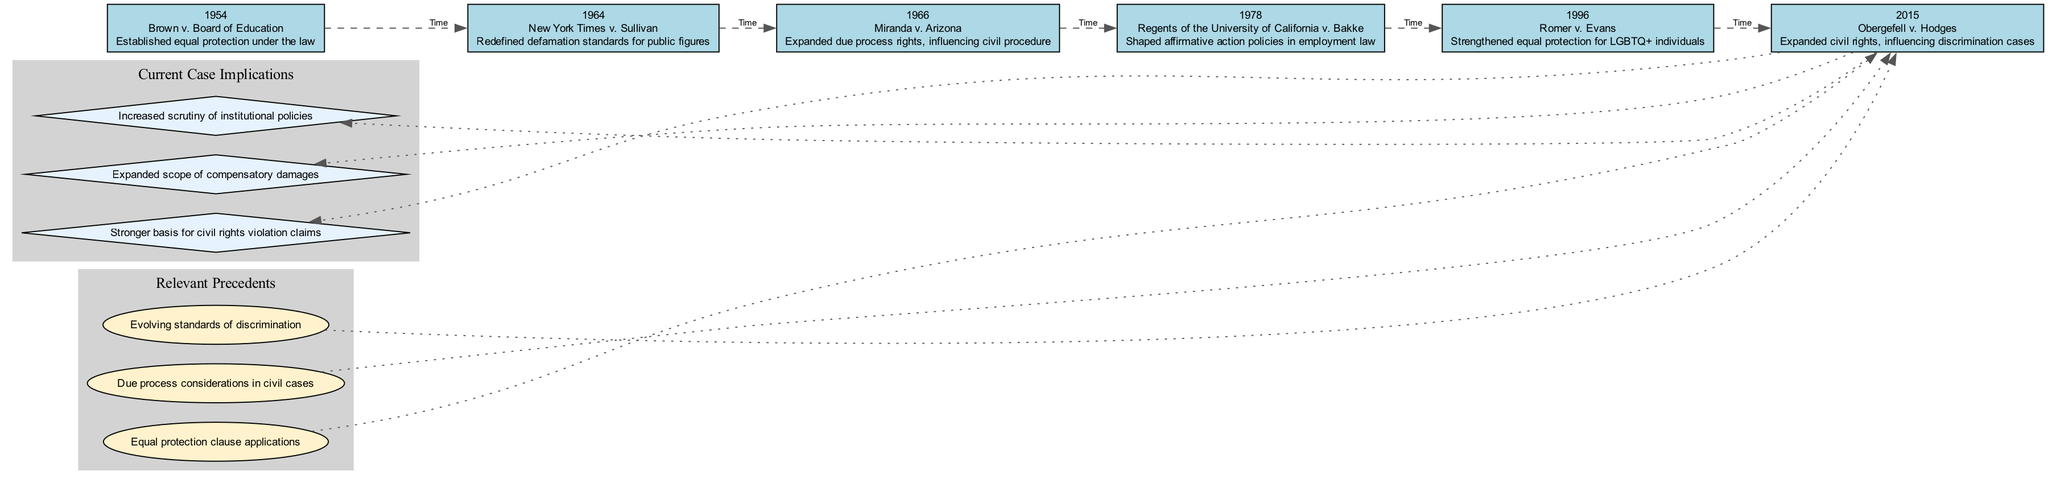What year did Brown v. Board of Education occur? The diagram lists "Brown v. Board of Education" under the year 1954, which is indicated as the first entry in the timeline.
Answer: 1954 How many cases are represented in the timeline? The timeline includes six cases, which can be counted from the list provided.
Answer: 6 What was the impact of Obergefell v. Hodges? The diagram states that "Obergefell v. Hodges" expanded civil rights and influenced discrimination cases, as indicated in the description for that particular case.
Answer: Expanded civil rights, influencing discrimination cases Which case had an impact on affirmative action policies? The diagram specifies that the impact of "Regents of the University of California v. Bakke" was to shape affirmative action policies in employment law, which is mentioned right after the year and case name.
Answer: Regents of the University of California v. Bakke What are the relevant precedents shown in the diagram? The diagram clusters several relevant precedents, including "Equal protection clause applications," "Due process considerations in civil cases," and "Evolving standards of discrimination," which can be clearly located within the cluster labeled 'Relevant Precedents.'
Answer: Equal protection clause applications, Due process considerations in civil cases, Evolving standards of discrimination How does the landmark case of Miranda v. Arizona influence modern tort law? The diagram indicates that "Miranda v. Arizona" expanded due process rights, which impacts civil procedure, meaning it plays a role in the broader context of modern tort law and legal standards applied in current cases.
Answer: Expanded due process rights, influencing civil procedure Which case is directly linked to the implications for civil rights violation claims? The diagram outlines that the implications of recent cases present a stronger basis for civil rights violation claims, specifically noting it in correlation with the final case on the timeline, which is "Obergefell v. Hodges."
Answer: Stronger basis for civil rights violation claims How many implications are associated with current cases? The diagram shows three implications listed under 'Current Case Implications,' indicating how many consequences or influences current cases have based on the timeline's context.
Answer: 3 Which case occurred last in the timeline? The last case in the timeline is "Obergefell v. Hodges," which appears as the final node on the horizontal layout of the timeline.
Answer: Obergefell v. Hodges What is a key feature of the timeline layout? The timeline is structured in a linear fashion from left to right, illustrating the chronological order of significant civil rights cases and their impacts over the years.
Answer: Linear fashion from left to right 